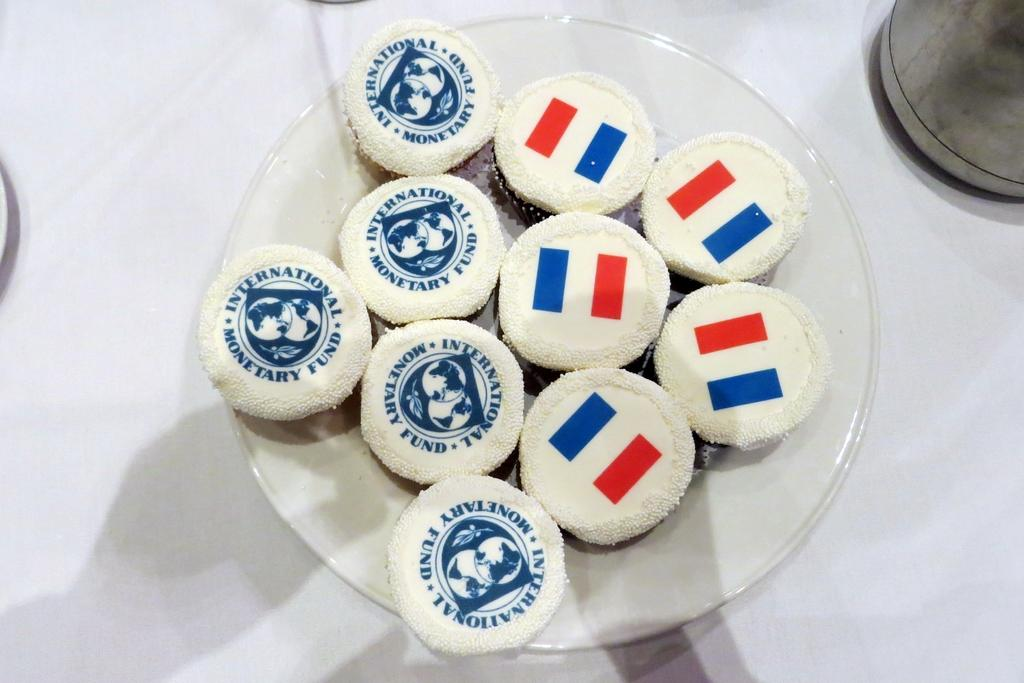What type of food can be seen in the image? There are cookies in the image. How are the cookies arranged or presented in the image? The cookies are placed in a plate. What type of clover is growing in the image? There is no clover present in the image; it features cookies placed in a plate. What type of corn can be seen in the image? There is no corn present in the image; it features cookies placed in a plate. 